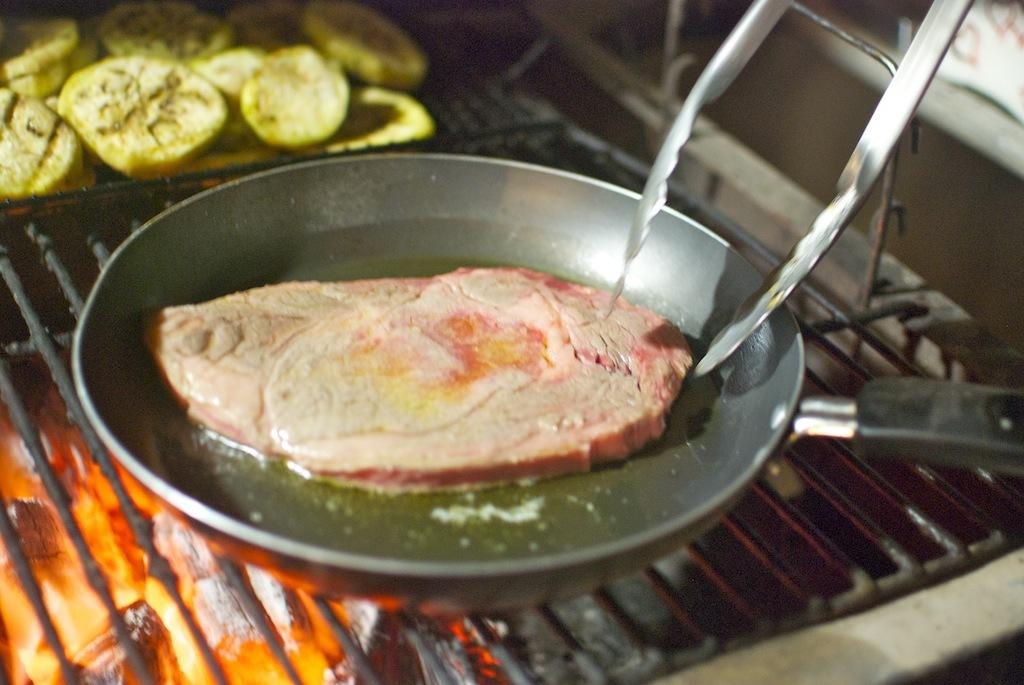What is on the pan in the image? There is meat on the pan in the image. What is the source of heat in the image? There is fire in the image. Who is present in the image? There is a girl in the image. What food item is beside the girl? There is a food item beside the girl. Can you tell me how many horses are visible on the roof in the image? There are no horses or roof present in the image. What type of sweater is the girl wearing in the image? There is no mention of a sweater in the image, so we cannot determine what type the girl might be wearing. 